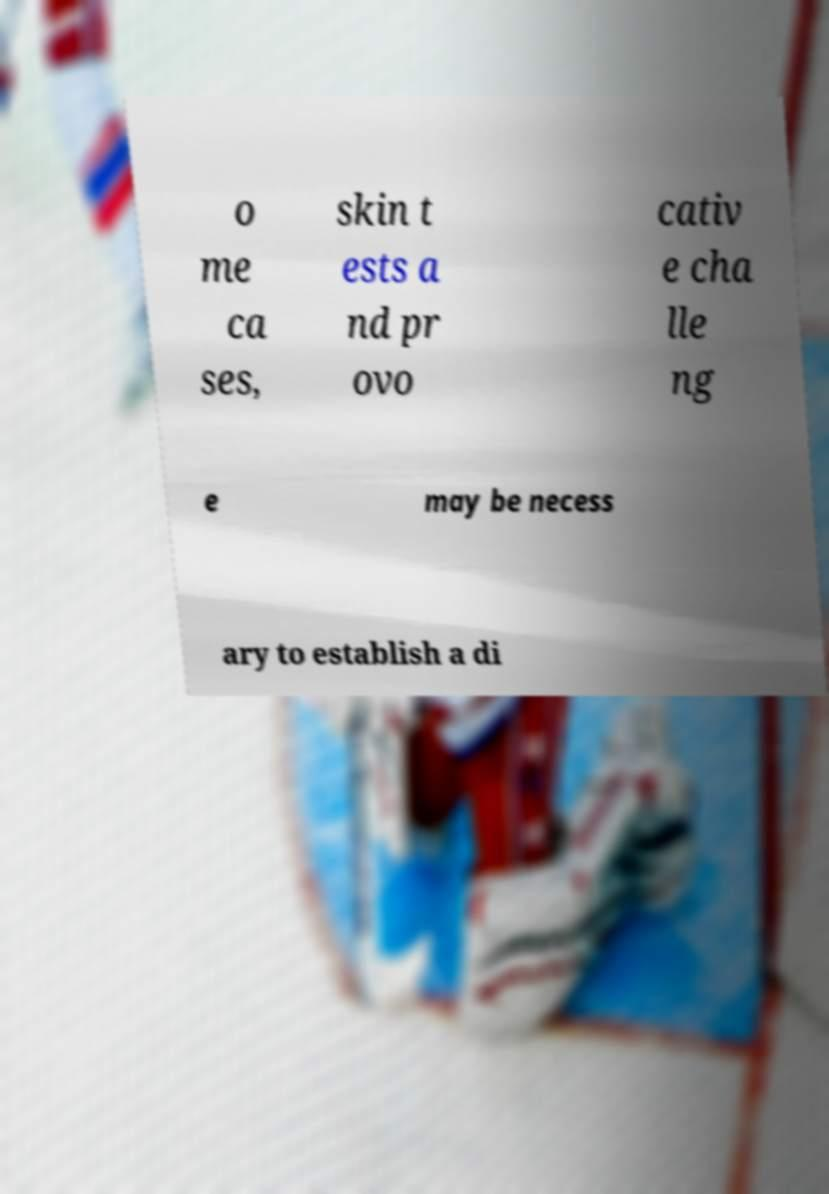Can you accurately transcribe the text from the provided image for me? o me ca ses, skin t ests a nd pr ovo cativ e cha lle ng e may be necess ary to establish a di 